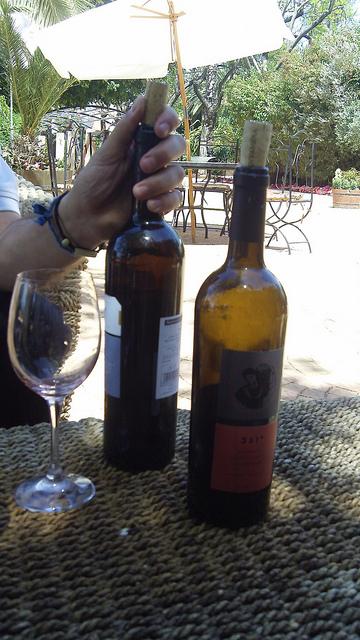What beverage is in the bottles?
Short answer required. Wine. What color are the bottles?
Quick response, please. Brown. What color is the umbrella pole?
Short answer required. Yellow. 